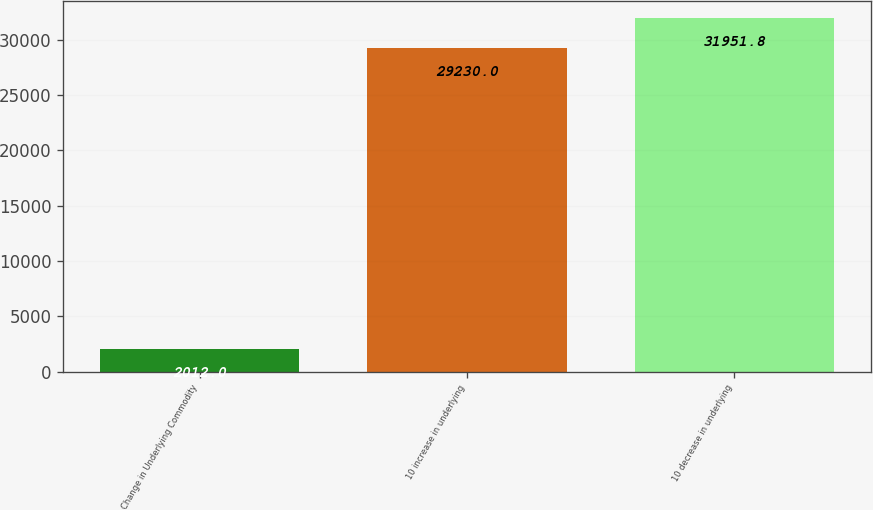Convert chart to OTSL. <chart><loc_0><loc_0><loc_500><loc_500><bar_chart><fcel>Change in Underlying Commodity<fcel>10 increase in underlying<fcel>10 decrease in underlying<nl><fcel>2012<fcel>29230<fcel>31951.8<nl></chart> 